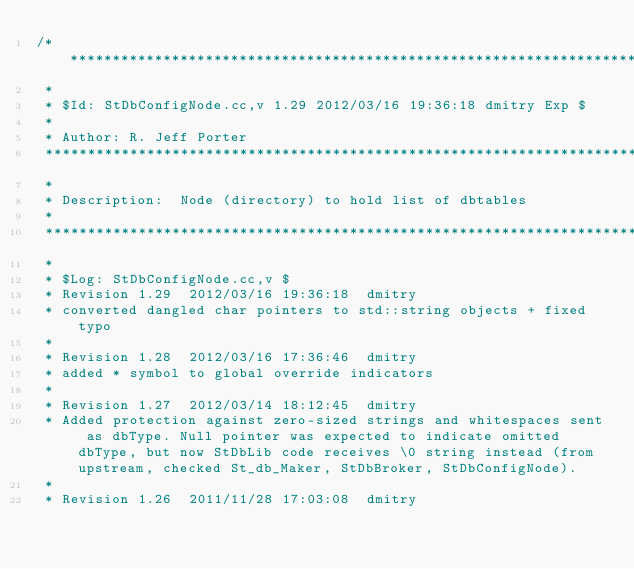Convert code to text. <code><loc_0><loc_0><loc_500><loc_500><_C++_>/***************************************************************************
 *
 * $Id: StDbConfigNode.cc,v 1.29 2012/03/16 19:36:18 dmitry Exp $
 *
 * Author: R. Jeff Porter
 ***************************************************************************
 *
 * Description:  Node (directory) to hold list of dbtables
 *
 ***************************************************************************
 *
 * $Log: StDbConfigNode.cc,v $
 * Revision 1.29  2012/03/16 19:36:18  dmitry
 * converted dangled char pointers to std::string objects + fixed typo
 *
 * Revision 1.28  2012/03/16 17:36:46  dmitry
 * added * symbol to global override indicators
 *
 * Revision 1.27  2012/03/14 18:12:45  dmitry
 * Added protection against zero-sized strings and whitespaces sent as dbType. Null pointer was expected to indicate omitted dbType, but now StDbLib code receives \0 string instead (from upstream, checked St_db_Maker, StDbBroker, StDbConfigNode).
 *
 * Revision 1.26  2011/11/28 17:03:08  dmitry</code> 